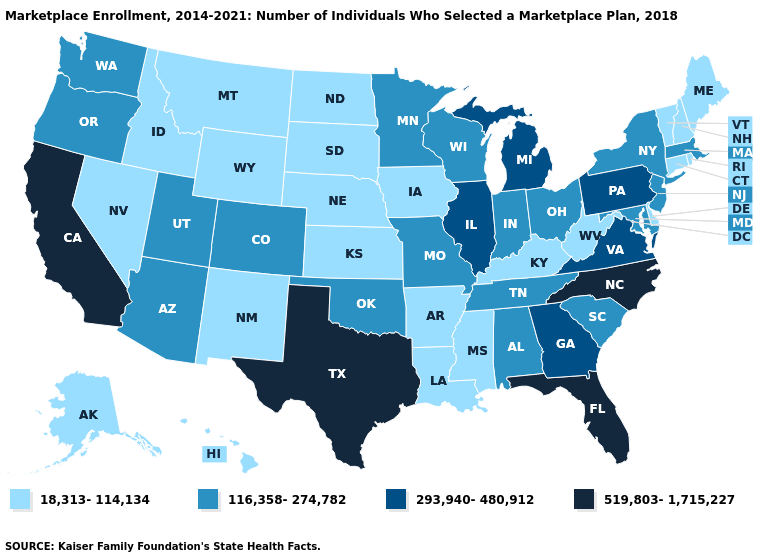Name the states that have a value in the range 519,803-1,715,227?
Keep it brief. California, Florida, North Carolina, Texas. What is the lowest value in states that border Kentucky?
Quick response, please. 18,313-114,134. Which states have the highest value in the USA?
Concise answer only. California, Florida, North Carolina, Texas. What is the highest value in states that border California?
Quick response, please. 116,358-274,782. Name the states that have a value in the range 519,803-1,715,227?
Short answer required. California, Florida, North Carolina, Texas. What is the highest value in the USA?
Answer briefly. 519,803-1,715,227. Name the states that have a value in the range 293,940-480,912?
Quick response, please. Georgia, Illinois, Michigan, Pennsylvania, Virginia. Does Vermont have a higher value than North Dakota?
Concise answer only. No. Name the states that have a value in the range 18,313-114,134?
Write a very short answer. Alaska, Arkansas, Connecticut, Delaware, Hawaii, Idaho, Iowa, Kansas, Kentucky, Louisiana, Maine, Mississippi, Montana, Nebraska, Nevada, New Hampshire, New Mexico, North Dakota, Rhode Island, South Dakota, Vermont, West Virginia, Wyoming. How many symbols are there in the legend?
Give a very brief answer. 4. Among the states that border Colorado , does Arizona have the highest value?
Be succinct. Yes. What is the lowest value in the West?
Be succinct. 18,313-114,134. Which states have the highest value in the USA?
Quick response, please. California, Florida, North Carolina, Texas. Does Illinois have the lowest value in the USA?
Write a very short answer. No. Which states have the lowest value in the Northeast?
Quick response, please. Connecticut, Maine, New Hampshire, Rhode Island, Vermont. 